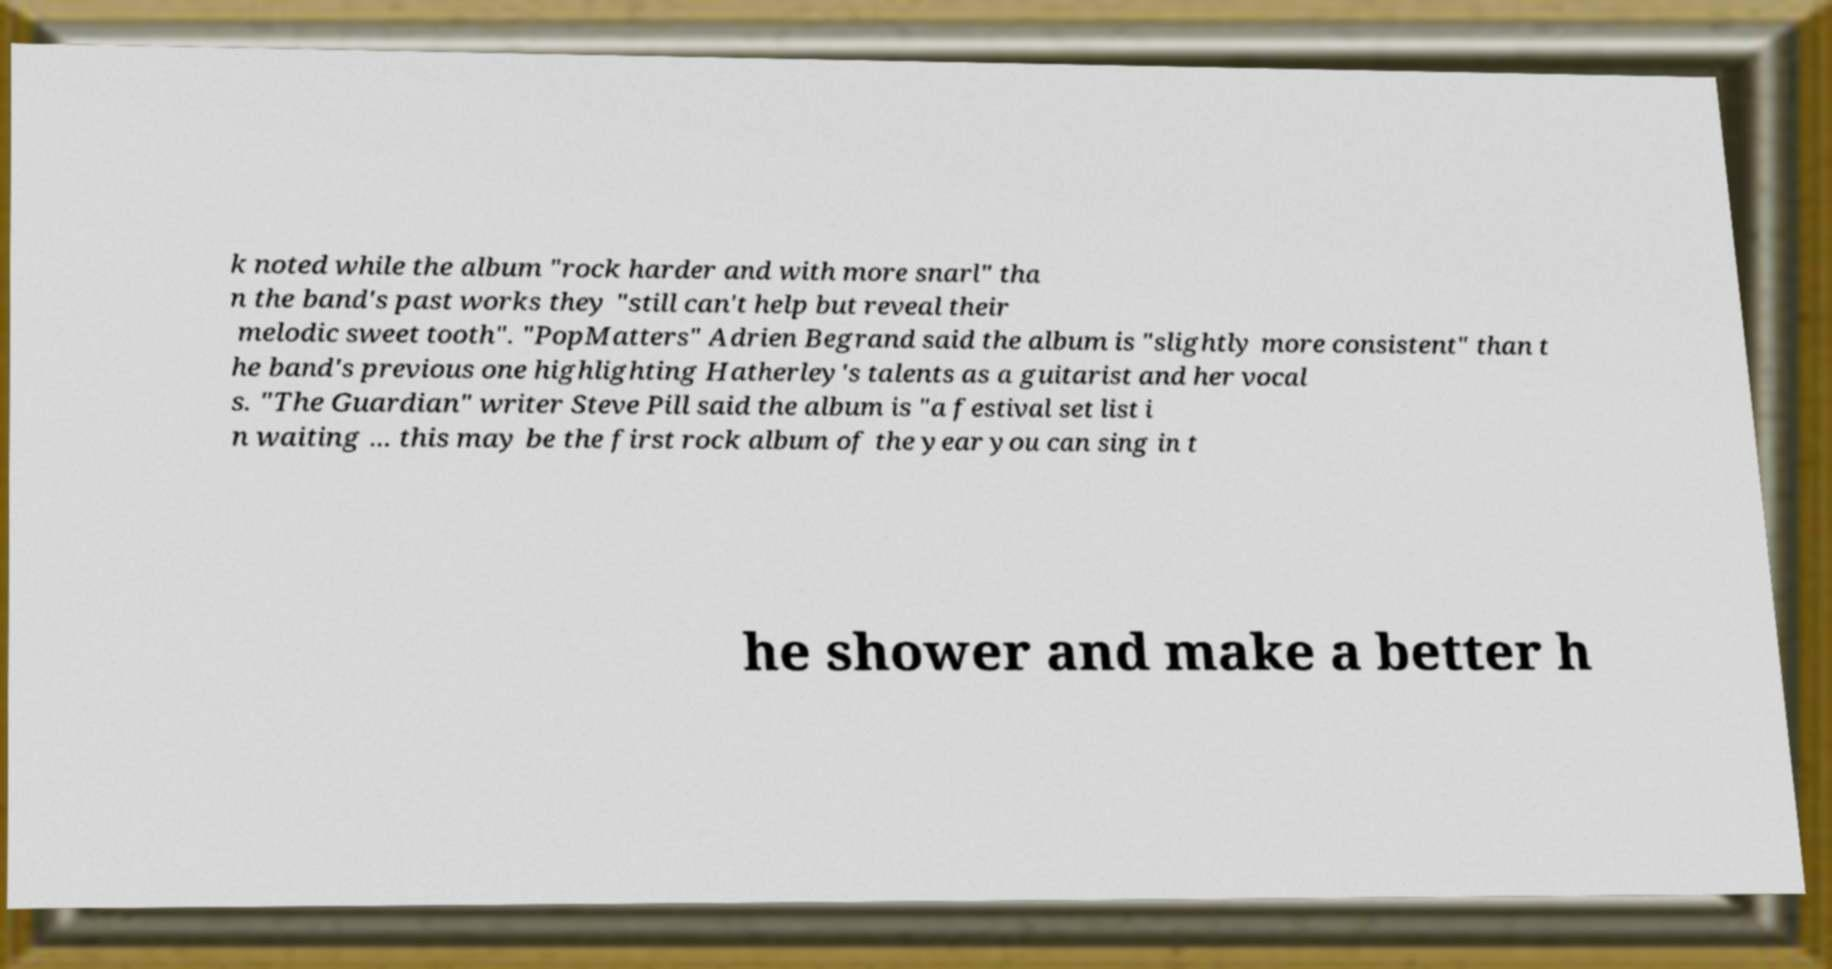Please read and relay the text visible in this image. What does it say? k noted while the album "rock harder and with more snarl" tha n the band's past works they "still can't help but reveal their melodic sweet tooth". "PopMatters" Adrien Begrand said the album is "slightly more consistent" than t he band's previous one highlighting Hatherley's talents as a guitarist and her vocal s. "The Guardian" writer Steve Pill said the album is "a festival set list i n waiting ... this may be the first rock album of the year you can sing in t he shower and make a better h 